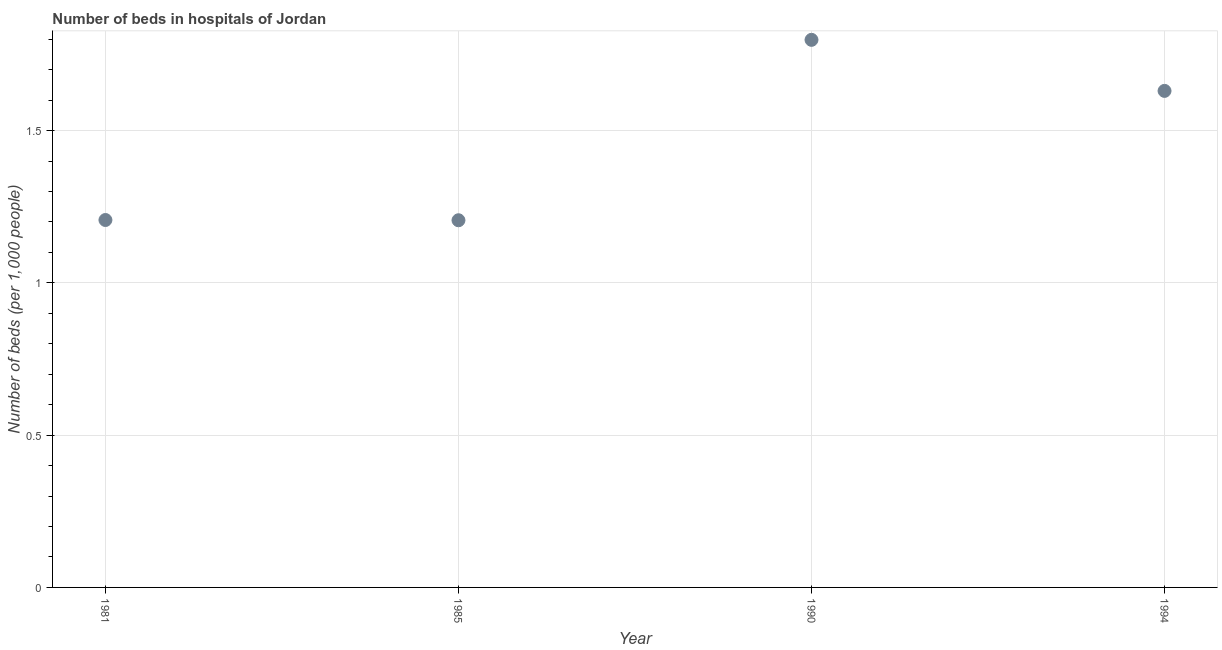What is the number of hospital beds in 1994?
Your answer should be very brief. 1.63. Across all years, what is the maximum number of hospital beds?
Your response must be concise. 1.8. Across all years, what is the minimum number of hospital beds?
Provide a short and direct response. 1.21. What is the sum of the number of hospital beds?
Ensure brevity in your answer.  5.84. What is the difference between the number of hospital beds in 1981 and 1990?
Your answer should be compact. -0.59. What is the average number of hospital beds per year?
Keep it short and to the point. 1.46. What is the median number of hospital beds?
Offer a terse response. 1.42. Do a majority of the years between 1990 and 1985 (inclusive) have number of hospital beds greater than 1.2 %?
Ensure brevity in your answer.  No. What is the ratio of the number of hospital beds in 1990 to that in 1994?
Offer a very short reply. 1.1. Is the difference between the number of hospital beds in 1981 and 1990 greater than the difference between any two years?
Provide a short and direct response. No. What is the difference between the highest and the second highest number of hospital beds?
Keep it short and to the point. 0.17. What is the difference between the highest and the lowest number of hospital beds?
Your answer should be compact. 0.59. How many dotlines are there?
Make the answer very short. 1. Are the values on the major ticks of Y-axis written in scientific E-notation?
Make the answer very short. No. What is the title of the graph?
Give a very brief answer. Number of beds in hospitals of Jordan. What is the label or title of the X-axis?
Offer a very short reply. Year. What is the label or title of the Y-axis?
Make the answer very short. Number of beds (per 1,0 people). What is the Number of beds (per 1,000 people) in 1981?
Your answer should be compact. 1.21. What is the Number of beds (per 1,000 people) in 1985?
Your response must be concise. 1.21. What is the Number of beds (per 1,000 people) in 1990?
Provide a succinct answer. 1.8. What is the Number of beds (per 1,000 people) in 1994?
Provide a short and direct response. 1.63. What is the difference between the Number of beds (per 1,000 people) in 1981 and 1985?
Give a very brief answer. 0. What is the difference between the Number of beds (per 1,000 people) in 1981 and 1990?
Provide a succinct answer. -0.59. What is the difference between the Number of beds (per 1,000 people) in 1981 and 1994?
Give a very brief answer. -0.42. What is the difference between the Number of beds (per 1,000 people) in 1985 and 1990?
Your response must be concise. -0.59. What is the difference between the Number of beds (per 1,000 people) in 1985 and 1994?
Ensure brevity in your answer.  -0.42. What is the difference between the Number of beds (per 1,000 people) in 1990 and 1994?
Keep it short and to the point. 0.17. What is the ratio of the Number of beds (per 1,000 people) in 1981 to that in 1990?
Offer a terse response. 0.67. What is the ratio of the Number of beds (per 1,000 people) in 1981 to that in 1994?
Make the answer very short. 0.74. What is the ratio of the Number of beds (per 1,000 people) in 1985 to that in 1990?
Ensure brevity in your answer.  0.67. What is the ratio of the Number of beds (per 1,000 people) in 1985 to that in 1994?
Your answer should be compact. 0.74. What is the ratio of the Number of beds (per 1,000 people) in 1990 to that in 1994?
Make the answer very short. 1.1. 